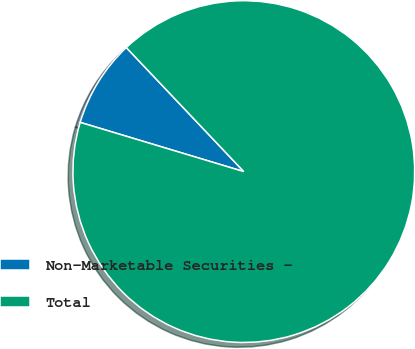Convert chart. <chart><loc_0><loc_0><loc_500><loc_500><pie_chart><fcel>Non-Marketable Securities -<fcel>Total<nl><fcel>8.28%<fcel>91.72%<nl></chart> 